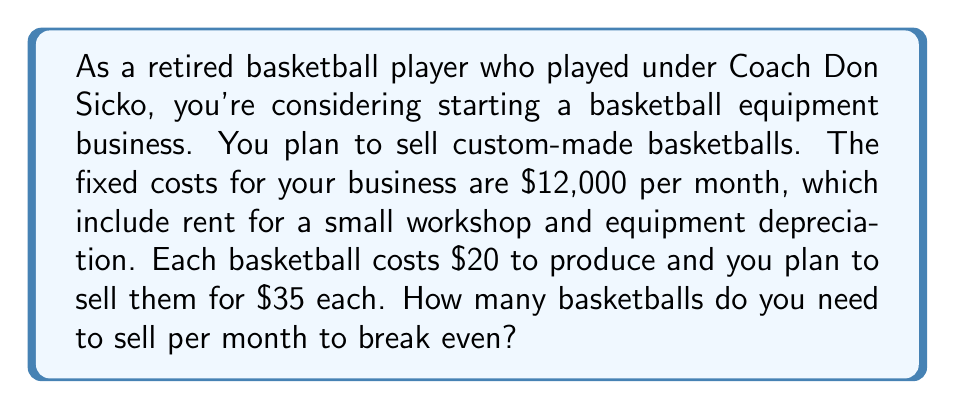Help me with this question. To solve this problem, we need to use the break-even formula:

$$ \text{Break-even point} = \frac{\text{Fixed Costs}}{\text{Price per unit} - \text{Variable Cost per unit}} $$

Let's define our variables:
- Fixed Costs (FC) = $12,000 per month
- Price per unit (P) = $35
- Variable Cost per unit (VC) = $20

Now, let's plug these values into our formula:

$$ \text{Break-even point} = \frac{12000}{35 - 20} = \frac{12000}{15} $$

Solving this equation:

$$ \text{Break-even point} = 800 $$

To verify, let's check the total revenue and total costs at 800 units:

Total Revenue: $800 \times $35 = $28,000
Total Costs: $12,000 + ($20 \times 800) = $28,000

Since Total Revenue equals Total Costs at 800 units, this confirms our break-even point.
Answer: You need to sell 800 basketballs per month to break even. 